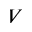<formula> <loc_0><loc_0><loc_500><loc_500>V</formula> 